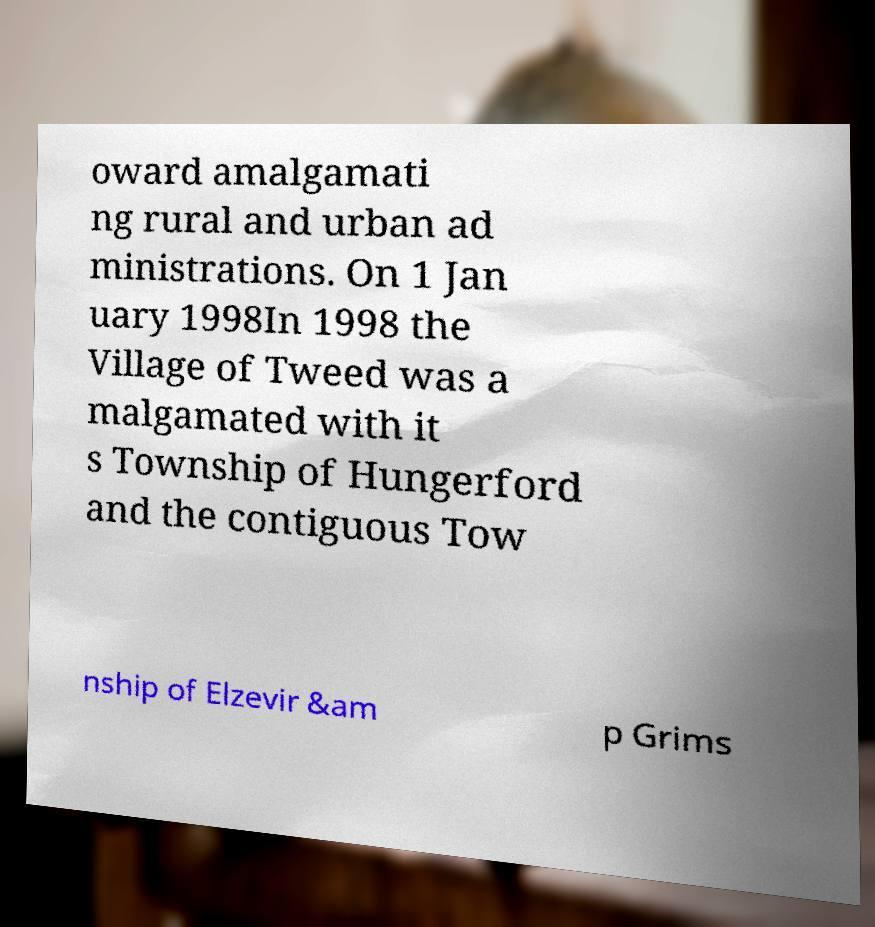There's text embedded in this image that I need extracted. Can you transcribe it verbatim? oward amalgamati ng rural and urban ad ministrations. On 1 Jan uary 1998In 1998 the Village of Tweed was a malgamated with it s Township of Hungerford and the contiguous Tow nship of Elzevir &am p Grims 